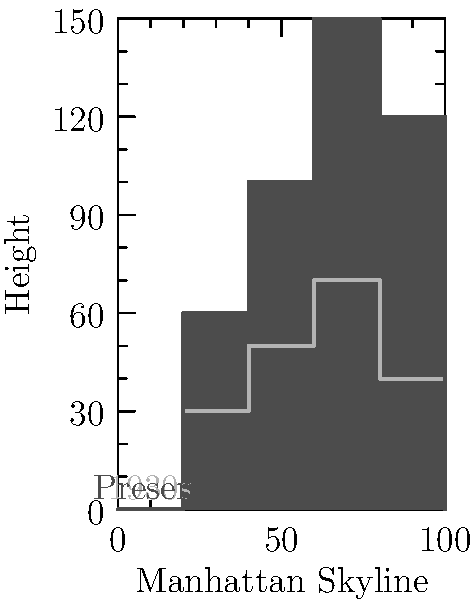Based on the aerial view comparison of Manhattan's skyline from the 1930s to the present day, what is the approximate percentage increase in the average building height? To determine the percentage increase in average building height, let's follow these steps:

1. Estimate the average height of buildings in the 1930s:
   The 1930s skyline shows heights roughly between 30 and 70 units.
   Estimated average: $(30 + 70) / 2 = 50$ units

2. Estimate the average height of buildings in the present day:
   The present-day skyline shows heights roughly between 60 and 150 units.
   Estimated average: $(60 + 150) / 2 = 105$ units

3. Calculate the increase in average height:
   $105 - 50 = 55$ units

4. Calculate the percentage increase:
   Percentage increase = $\frac{\text{Increase}}{\text{Original}} \times 100\%$
   $= \frac{55}{50} \times 100\% = 110\%$

Therefore, the approximate percentage increase in the average building height from the 1930s to the present day is 110%.
Answer: 110% 